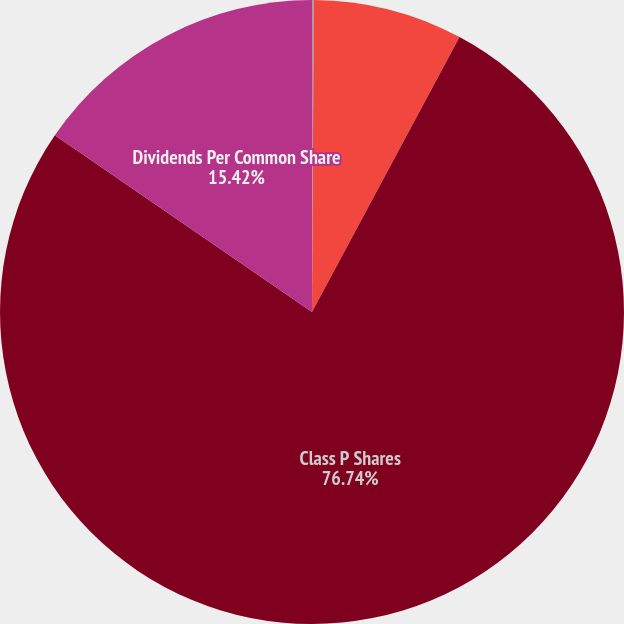Convert chart. <chart><loc_0><loc_0><loc_500><loc_500><pie_chart><fcel>Basic and Diluted Earnings Per<fcel>Total Basic and Diluted<fcel>Class P Shares<fcel>Dividends Per Common Share<nl><fcel>0.09%<fcel>7.75%<fcel>76.75%<fcel>15.42%<nl></chart> 